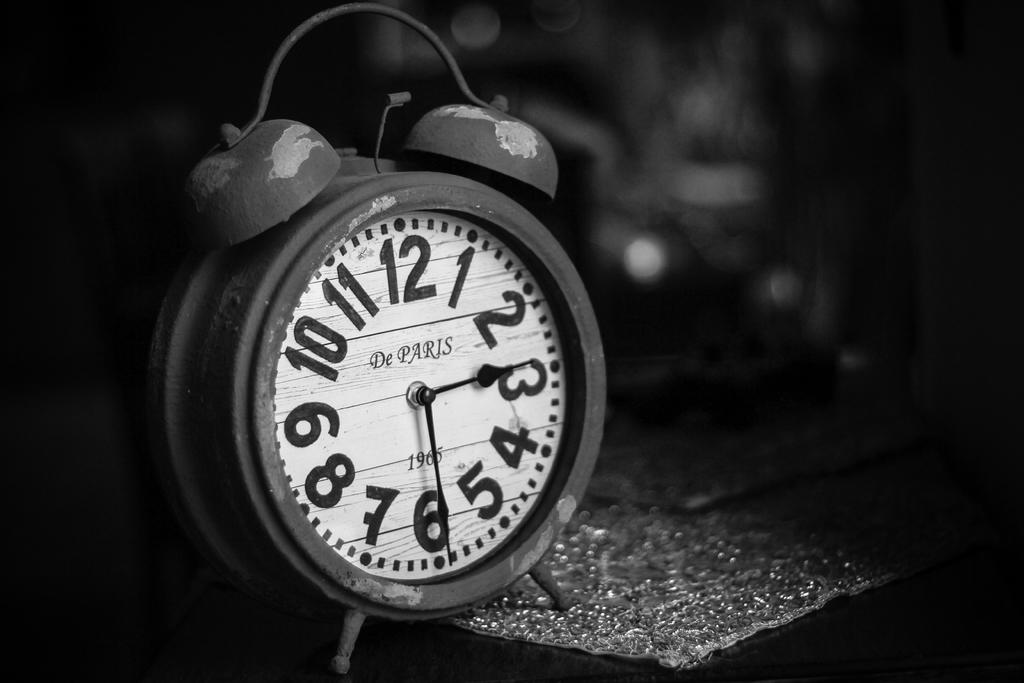<image>
Offer a succinct explanation of the picture presented. the number 3 is on the white clock on the table 